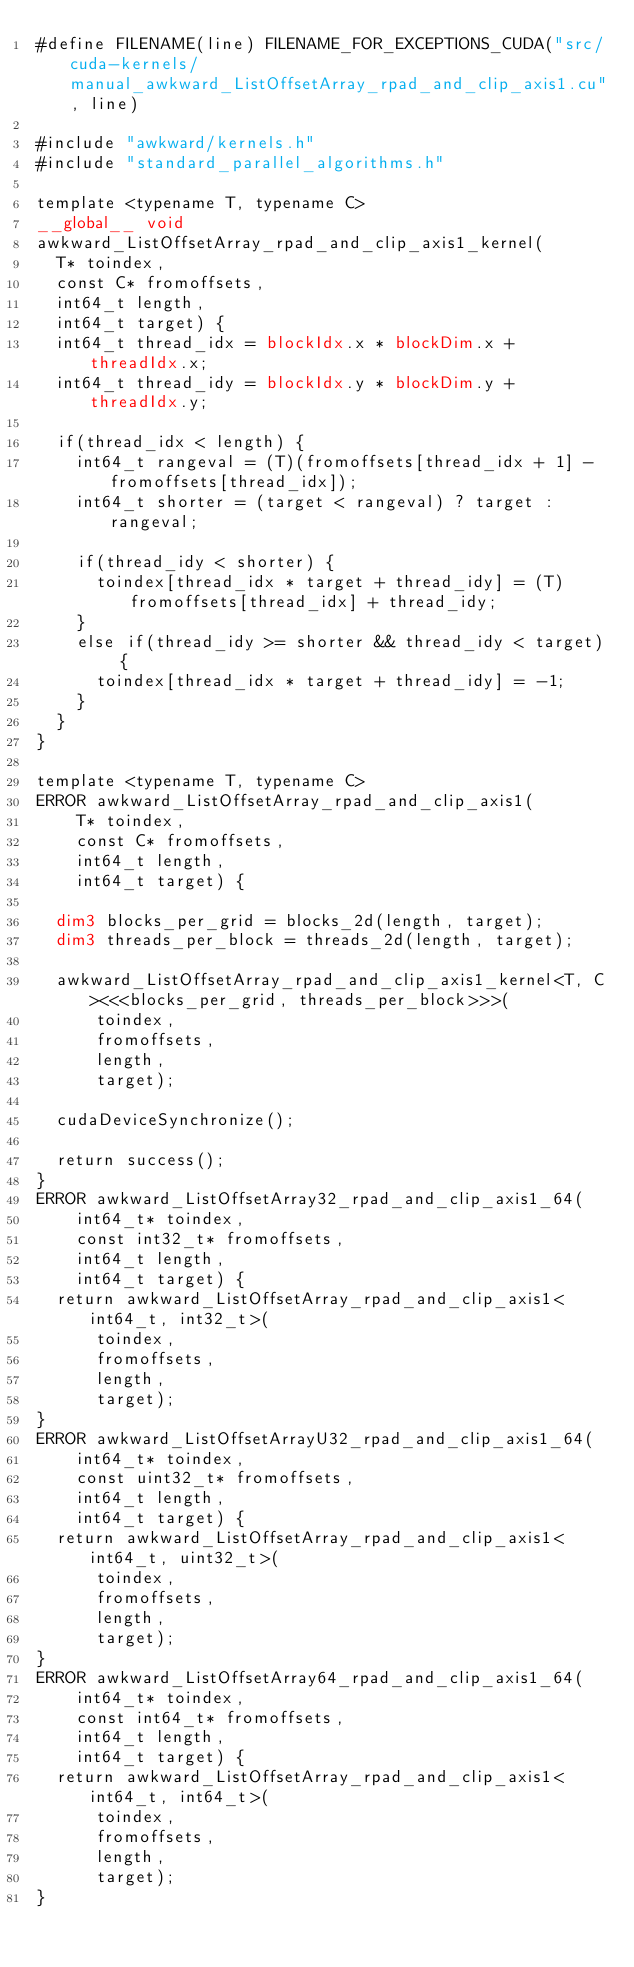<code> <loc_0><loc_0><loc_500><loc_500><_Cuda_>#define FILENAME(line) FILENAME_FOR_EXCEPTIONS_CUDA("src/cuda-kernels/manual_awkward_ListOffsetArray_rpad_and_clip_axis1.cu", line)

#include "awkward/kernels.h"
#include "standard_parallel_algorithms.h"

template <typename T, typename C>
__global__ void
awkward_ListOffsetArray_rpad_and_clip_axis1_kernel(
  T* toindex,
  const C* fromoffsets,
  int64_t length,
  int64_t target) {
  int64_t thread_idx = blockIdx.x * blockDim.x + threadIdx.x;
  int64_t thread_idy = blockIdx.y * blockDim.y + threadIdx.y;

  if(thread_idx < length) {
    int64_t rangeval = (T)(fromoffsets[thread_idx + 1] - fromoffsets[thread_idx]);
    int64_t shorter = (target < rangeval) ? target : rangeval;

	if(thread_idy < shorter) {
      toindex[thread_idx * target + thread_idy] = (T)fromoffsets[thread_idx] + thread_idy;
    }
	else if(thread_idy >= shorter && thread_idy < target) {
      toindex[thread_idx * target + thread_idy] = -1;
    }
  }
}

template <typename T, typename C>
ERROR awkward_ListOffsetArray_rpad_and_clip_axis1(
    T* toindex,
    const C* fromoffsets,
    int64_t length,
    int64_t target) {

  dim3 blocks_per_grid = blocks_2d(length, target);
  dim3 threads_per_block = threads_2d(length, target);

  awkward_ListOffsetArray_rpad_and_clip_axis1_kernel<T, C><<<blocks_per_grid, threads_per_block>>>(
      toindex,
      fromoffsets,
      length,
      target);

  cudaDeviceSynchronize();

  return success();
}
ERROR awkward_ListOffsetArray32_rpad_and_clip_axis1_64(
    int64_t* toindex,
    const int32_t* fromoffsets,
    int64_t length,
    int64_t target) {
  return awkward_ListOffsetArray_rpad_and_clip_axis1<int64_t, int32_t>(
      toindex,
      fromoffsets,
      length,
      target);
}
ERROR awkward_ListOffsetArrayU32_rpad_and_clip_axis1_64(
    int64_t* toindex,
    const uint32_t* fromoffsets,
    int64_t length,
    int64_t target) {
  return awkward_ListOffsetArray_rpad_and_clip_axis1<int64_t, uint32_t>(
      toindex,
      fromoffsets,
      length,
      target);
}
ERROR awkward_ListOffsetArray64_rpad_and_clip_axis1_64(
    int64_t* toindex,
    const int64_t* fromoffsets,
    int64_t length,
    int64_t target) {
  return awkward_ListOffsetArray_rpad_and_clip_axis1<int64_t, int64_t>(
      toindex,
      fromoffsets,
      length,
      target);
}
</code> 